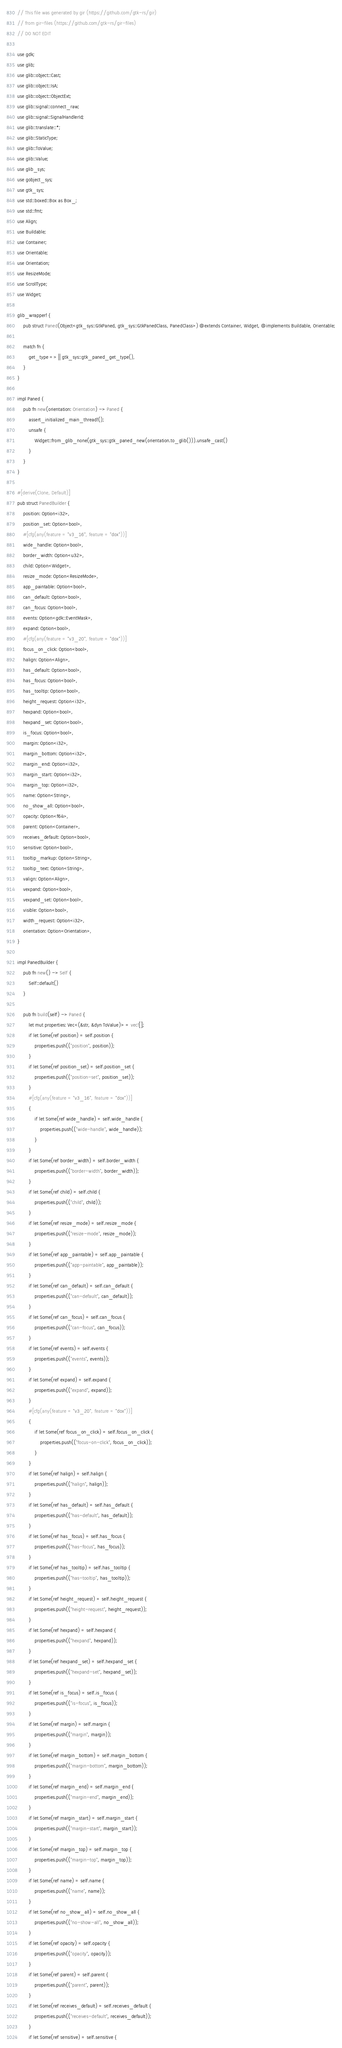<code> <loc_0><loc_0><loc_500><loc_500><_Rust_>// This file was generated by gir (https://github.com/gtk-rs/gir)
// from gir-files (https://github.com/gtk-rs/gir-files)
// DO NOT EDIT

use gdk;
use glib;
use glib::object::Cast;
use glib::object::IsA;
use glib::object::ObjectExt;
use glib::signal::connect_raw;
use glib::signal::SignalHandlerId;
use glib::translate::*;
use glib::StaticType;
use glib::ToValue;
use glib::Value;
use glib_sys;
use gobject_sys;
use gtk_sys;
use std::boxed::Box as Box_;
use std::fmt;
use Align;
use Buildable;
use Container;
use Orientable;
use Orientation;
use ResizeMode;
use ScrollType;
use Widget;

glib_wrapper! {
    pub struct Paned(Object<gtk_sys::GtkPaned, gtk_sys::GtkPanedClass, PanedClass>) @extends Container, Widget, @implements Buildable, Orientable;

    match fn {
        get_type => || gtk_sys::gtk_paned_get_type(),
    }
}

impl Paned {
    pub fn new(orientation: Orientation) -> Paned {
        assert_initialized_main_thread!();
        unsafe {
            Widget::from_glib_none(gtk_sys::gtk_paned_new(orientation.to_glib())).unsafe_cast()
        }
    }
}

#[derive(Clone, Default)]
pub struct PanedBuilder {
    position: Option<i32>,
    position_set: Option<bool>,
    #[cfg(any(feature = "v3_16", feature = "dox"))]
    wide_handle: Option<bool>,
    border_width: Option<u32>,
    child: Option<Widget>,
    resize_mode: Option<ResizeMode>,
    app_paintable: Option<bool>,
    can_default: Option<bool>,
    can_focus: Option<bool>,
    events: Option<gdk::EventMask>,
    expand: Option<bool>,
    #[cfg(any(feature = "v3_20", feature = "dox"))]
    focus_on_click: Option<bool>,
    halign: Option<Align>,
    has_default: Option<bool>,
    has_focus: Option<bool>,
    has_tooltip: Option<bool>,
    height_request: Option<i32>,
    hexpand: Option<bool>,
    hexpand_set: Option<bool>,
    is_focus: Option<bool>,
    margin: Option<i32>,
    margin_bottom: Option<i32>,
    margin_end: Option<i32>,
    margin_start: Option<i32>,
    margin_top: Option<i32>,
    name: Option<String>,
    no_show_all: Option<bool>,
    opacity: Option<f64>,
    parent: Option<Container>,
    receives_default: Option<bool>,
    sensitive: Option<bool>,
    tooltip_markup: Option<String>,
    tooltip_text: Option<String>,
    valign: Option<Align>,
    vexpand: Option<bool>,
    vexpand_set: Option<bool>,
    visible: Option<bool>,
    width_request: Option<i32>,
    orientation: Option<Orientation>,
}

impl PanedBuilder {
    pub fn new() -> Self {
        Self::default()
    }

    pub fn build(self) -> Paned {
        let mut properties: Vec<(&str, &dyn ToValue)> = vec![];
        if let Some(ref position) = self.position {
            properties.push(("position", position));
        }
        if let Some(ref position_set) = self.position_set {
            properties.push(("position-set", position_set));
        }
        #[cfg(any(feature = "v3_16", feature = "dox"))]
        {
            if let Some(ref wide_handle) = self.wide_handle {
                properties.push(("wide-handle", wide_handle));
            }
        }
        if let Some(ref border_width) = self.border_width {
            properties.push(("border-width", border_width));
        }
        if let Some(ref child) = self.child {
            properties.push(("child", child));
        }
        if let Some(ref resize_mode) = self.resize_mode {
            properties.push(("resize-mode", resize_mode));
        }
        if let Some(ref app_paintable) = self.app_paintable {
            properties.push(("app-paintable", app_paintable));
        }
        if let Some(ref can_default) = self.can_default {
            properties.push(("can-default", can_default));
        }
        if let Some(ref can_focus) = self.can_focus {
            properties.push(("can-focus", can_focus));
        }
        if let Some(ref events) = self.events {
            properties.push(("events", events));
        }
        if let Some(ref expand) = self.expand {
            properties.push(("expand", expand));
        }
        #[cfg(any(feature = "v3_20", feature = "dox"))]
        {
            if let Some(ref focus_on_click) = self.focus_on_click {
                properties.push(("focus-on-click", focus_on_click));
            }
        }
        if let Some(ref halign) = self.halign {
            properties.push(("halign", halign));
        }
        if let Some(ref has_default) = self.has_default {
            properties.push(("has-default", has_default));
        }
        if let Some(ref has_focus) = self.has_focus {
            properties.push(("has-focus", has_focus));
        }
        if let Some(ref has_tooltip) = self.has_tooltip {
            properties.push(("has-tooltip", has_tooltip));
        }
        if let Some(ref height_request) = self.height_request {
            properties.push(("height-request", height_request));
        }
        if let Some(ref hexpand) = self.hexpand {
            properties.push(("hexpand", hexpand));
        }
        if let Some(ref hexpand_set) = self.hexpand_set {
            properties.push(("hexpand-set", hexpand_set));
        }
        if let Some(ref is_focus) = self.is_focus {
            properties.push(("is-focus", is_focus));
        }
        if let Some(ref margin) = self.margin {
            properties.push(("margin", margin));
        }
        if let Some(ref margin_bottom) = self.margin_bottom {
            properties.push(("margin-bottom", margin_bottom));
        }
        if let Some(ref margin_end) = self.margin_end {
            properties.push(("margin-end", margin_end));
        }
        if let Some(ref margin_start) = self.margin_start {
            properties.push(("margin-start", margin_start));
        }
        if let Some(ref margin_top) = self.margin_top {
            properties.push(("margin-top", margin_top));
        }
        if let Some(ref name) = self.name {
            properties.push(("name", name));
        }
        if let Some(ref no_show_all) = self.no_show_all {
            properties.push(("no-show-all", no_show_all));
        }
        if let Some(ref opacity) = self.opacity {
            properties.push(("opacity", opacity));
        }
        if let Some(ref parent) = self.parent {
            properties.push(("parent", parent));
        }
        if let Some(ref receives_default) = self.receives_default {
            properties.push(("receives-default", receives_default));
        }
        if let Some(ref sensitive) = self.sensitive {</code> 